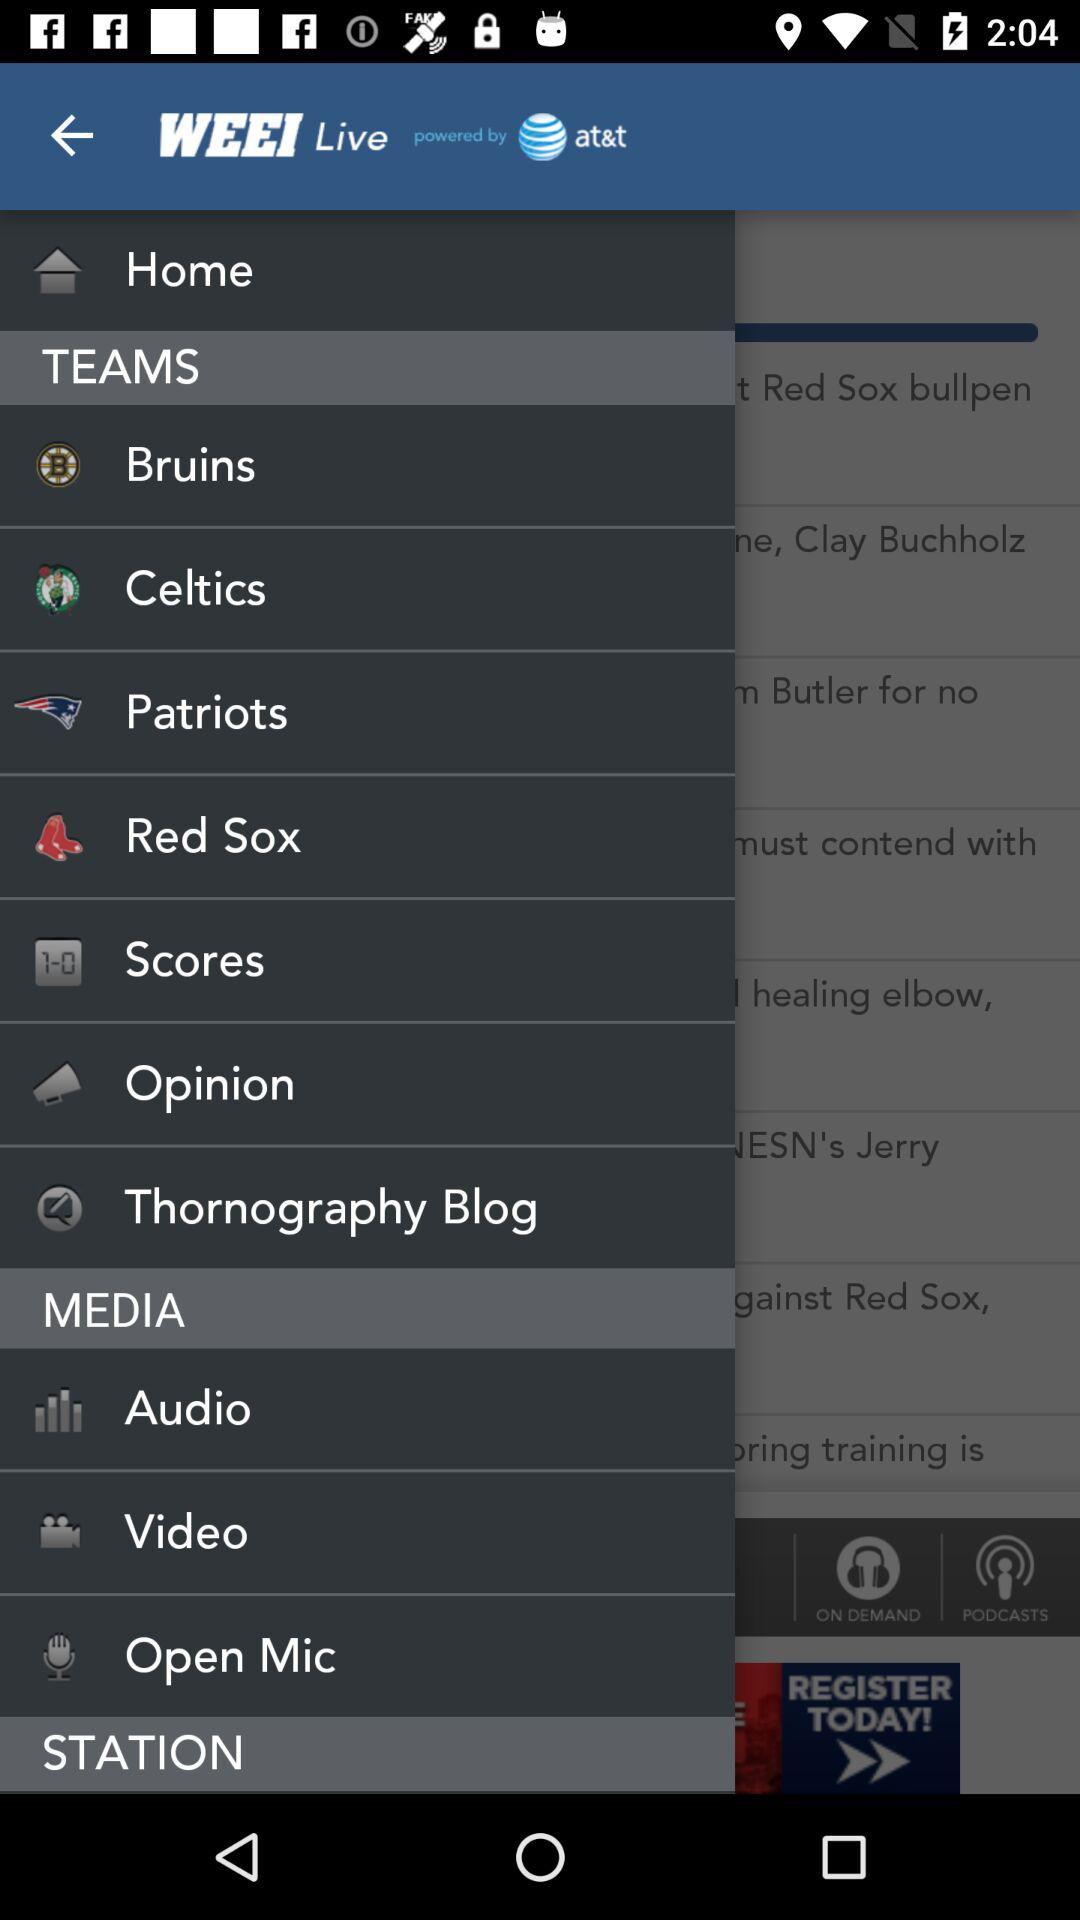Who has powered "WEEI live"? "WEEI live" is powered by AT&T. 